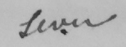Please transcribe the handwritten text in this image. seven 